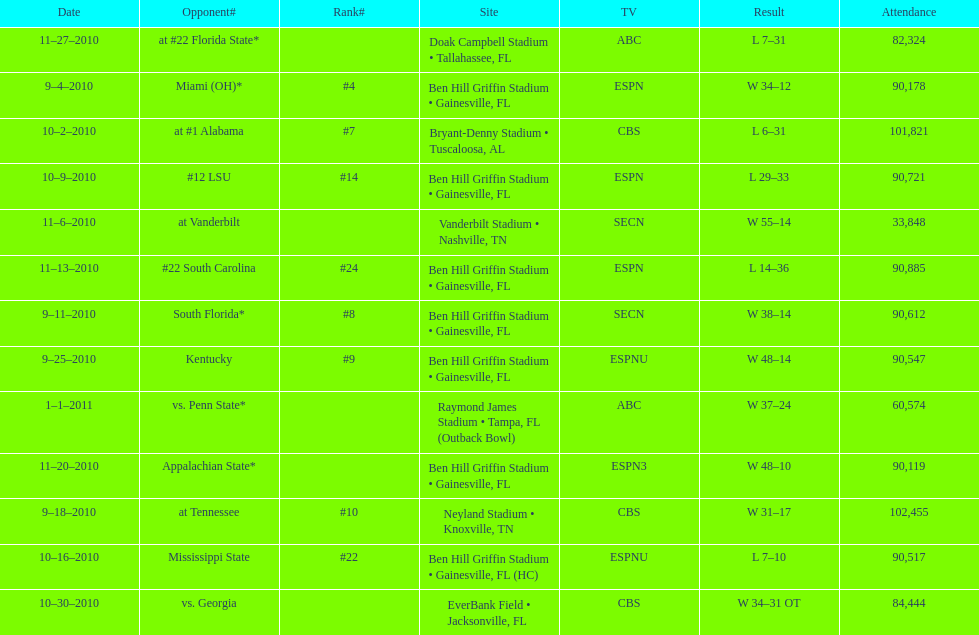In the last game, what was the difference in scores between the two sides? 13 points. 